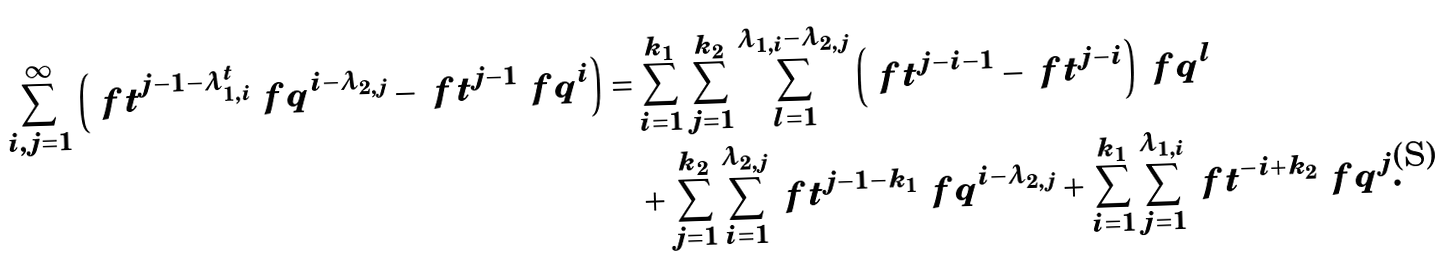<formula> <loc_0><loc_0><loc_500><loc_500>\sum _ { i , j = 1 } ^ { \infty } \left ( \ f t ^ { j - 1 - \lambda _ { 1 , i } ^ { t } } \ f q ^ { i - \lambda _ { 2 , j } } - \ f t ^ { j - 1 } \ f q ^ { i } \right ) = & \sum _ { i = 1 } ^ { k _ { 1 } } \sum _ { j = 1 } ^ { k _ { 2 } } \sum _ { l = 1 } ^ { \lambda _ { 1 , i } - \lambda _ { 2 , j } } \left ( \ f t ^ { j - i - 1 } - \ f t ^ { j - i } \right ) \ f q ^ { l } \\ & + \sum _ { j = 1 } ^ { k _ { 2 } } \sum _ { i = 1 } ^ { \lambda _ { 2 , j } } \ f t ^ { j - 1 - k _ { 1 } } \ f q ^ { i - \lambda _ { 2 , j } } + \sum _ { i = 1 } ^ { k _ { 1 } } \sum _ { j = 1 } ^ { \lambda _ { 1 , i } } \ f t ^ { - i + k _ { 2 } } \ f q ^ { j } .</formula> 